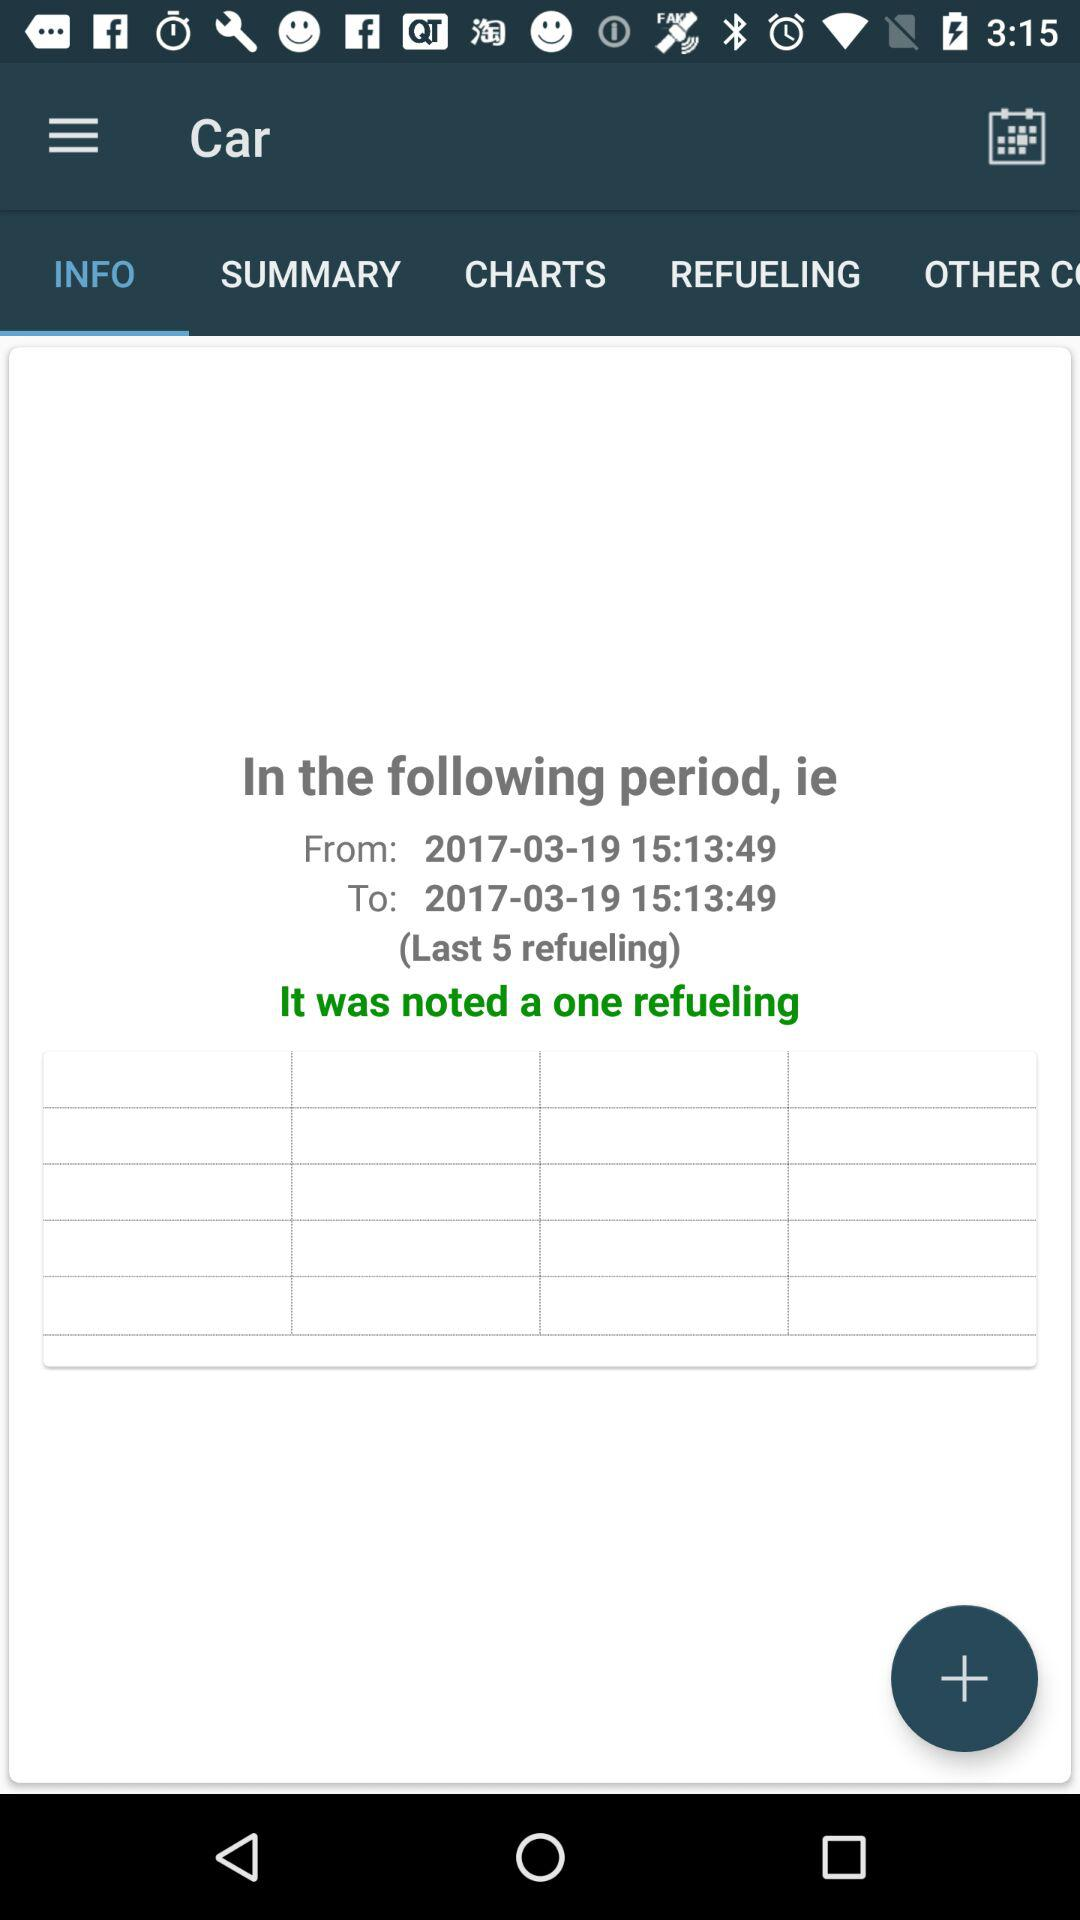How many refuelings are shown?
Answer the question using a single word or phrase. 1 